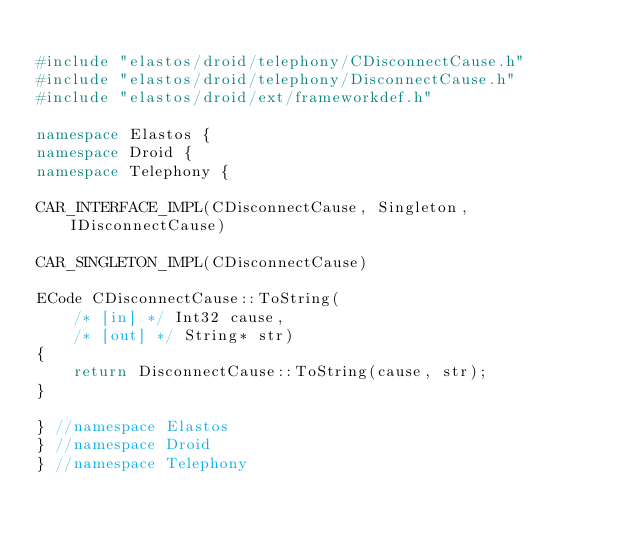Convert code to text. <code><loc_0><loc_0><loc_500><loc_500><_C++_>
#include "elastos/droid/telephony/CDisconnectCause.h"
#include "elastos/droid/telephony/DisconnectCause.h"
#include "elastos/droid/ext/frameworkdef.h"

namespace Elastos {
namespace Droid {
namespace Telephony {

CAR_INTERFACE_IMPL(CDisconnectCause, Singleton, IDisconnectCause)

CAR_SINGLETON_IMPL(CDisconnectCause)

ECode CDisconnectCause::ToString(
    /* [in] */ Int32 cause,
    /* [out] */ String* str)
{
    return DisconnectCause::ToString(cause, str);
}

} //namespace Elastos
} //namespace Droid
} //namespace Telephony</code> 